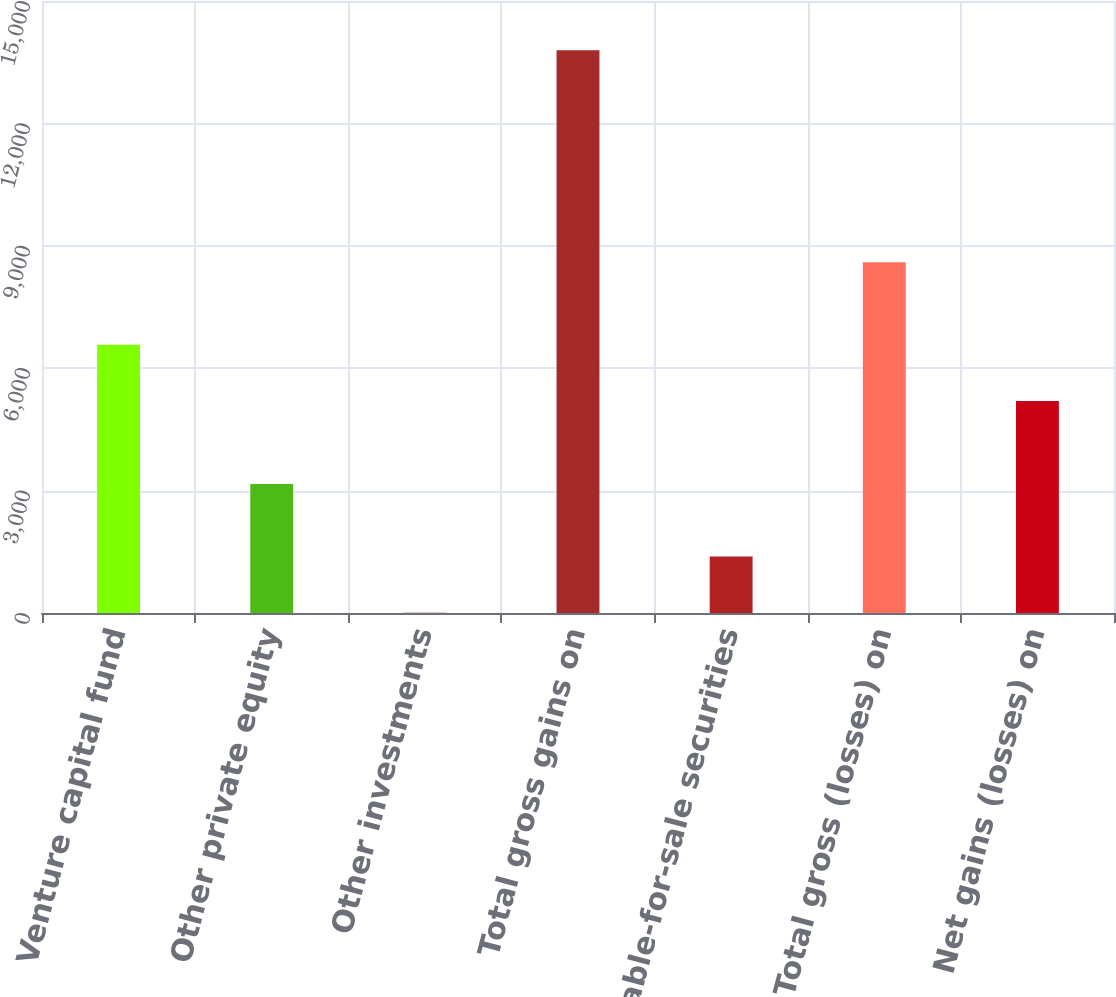Convert chart. <chart><loc_0><loc_0><loc_500><loc_500><bar_chart><fcel>Venture capital fund<fcel>Other private equity<fcel>Other investments<fcel>Total gross gains on<fcel>Available-for-sale securities<fcel>Total gross (losses) on<fcel>Net gains (losses) on<nl><fcel>6576.6<fcel>3163<fcel>7<fcel>13793<fcel>1385.6<fcel>8595<fcel>5198<nl></chart> 